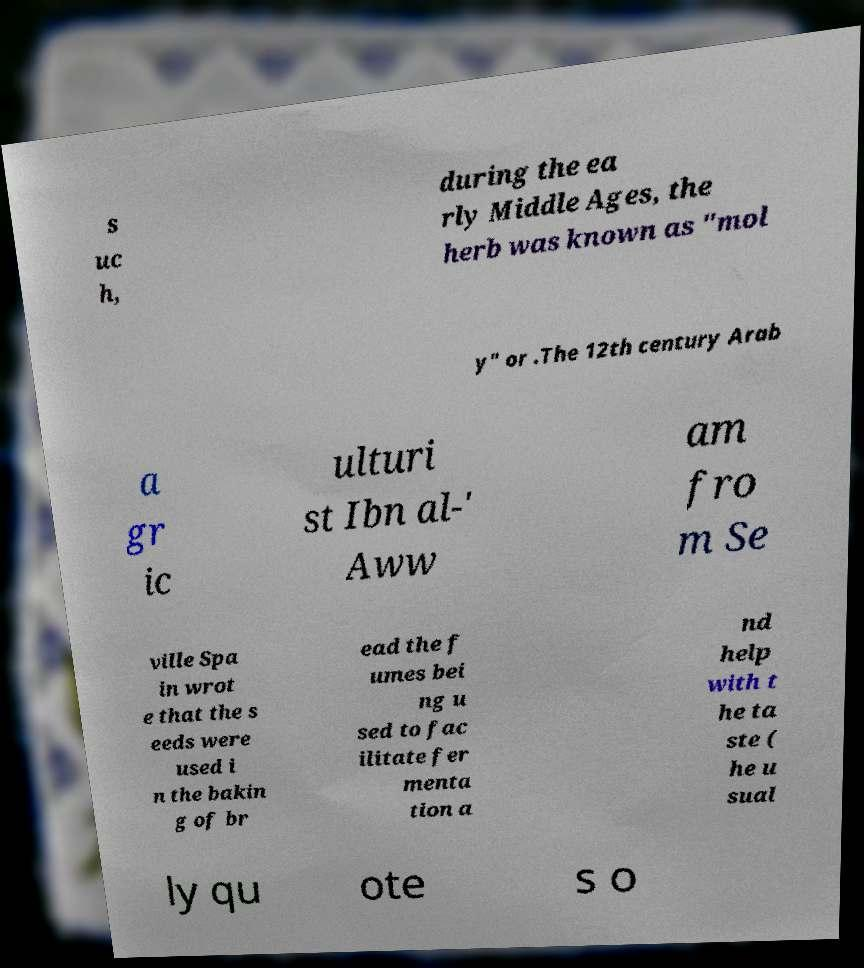For documentation purposes, I need the text within this image transcribed. Could you provide that? s uc h, during the ea rly Middle Ages, the herb was known as "mol y" or .The 12th century Arab a gr ic ulturi st Ibn al-' Aww am fro m Se ville Spa in wrot e that the s eeds were used i n the bakin g of br ead the f umes bei ng u sed to fac ilitate fer menta tion a nd help with t he ta ste ( he u sual ly qu ote s o 